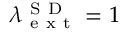<formula> <loc_0><loc_0><loc_500><loc_500>\lambda _ { e x t } ^ { S D } = 1</formula> 